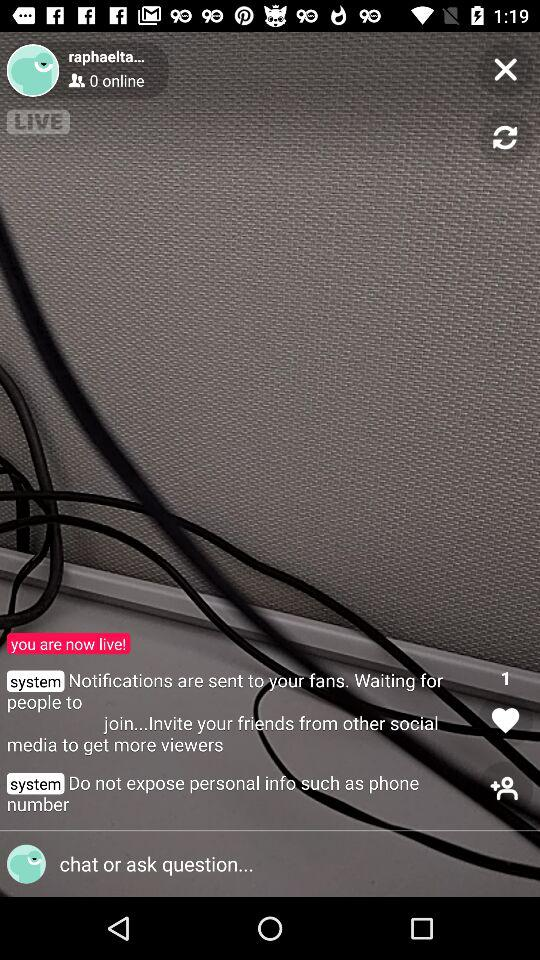How many people are online? Based on the image, there are 0 people online, as indicated by the user interface of the live streaming service, which shows '0 online'. This figure represents the number of viewers currently watching the live stream. 